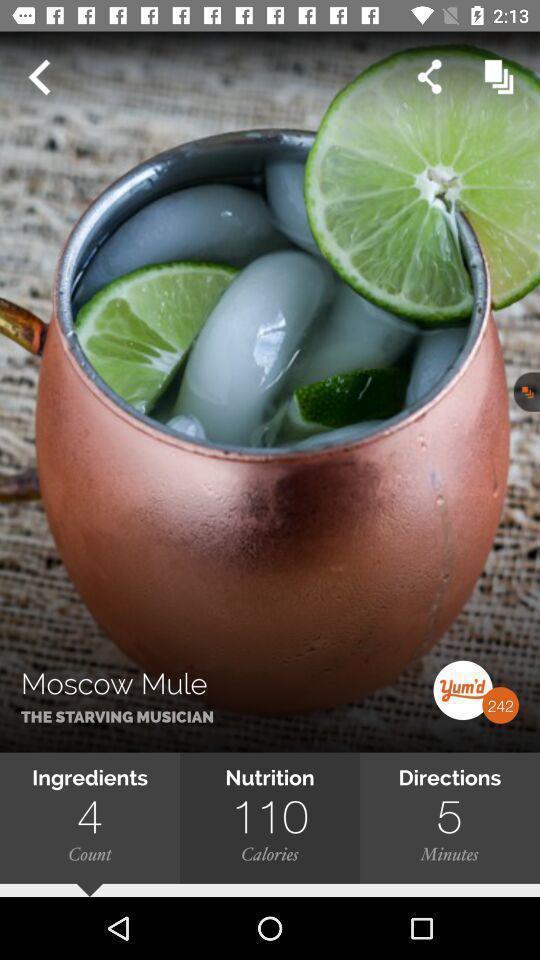What is the overall content of this screenshot? Screen page displaying an image with various options in application. 